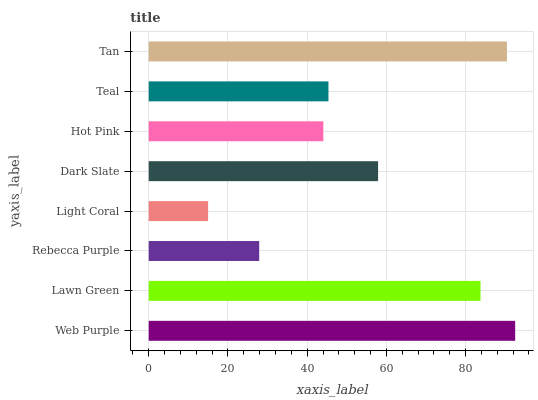Is Light Coral the minimum?
Answer yes or no. Yes. Is Web Purple the maximum?
Answer yes or no. Yes. Is Lawn Green the minimum?
Answer yes or no. No. Is Lawn Green the maximum?
Answer yes or no. No. Is Web Purple greater than Lawn Green?
Answer yes or no. Yes. Is Lawn Green less than Web Purple?
Answer yes or no. Yes. Is Lawn Green greater than Web Purple?
Answer yes or no. No. Is Web Purple less than Lawn Green?
Answer yes or no. No. Is Dark Slate the high median?
Answer yes or no. Yes. Is Teal the low median?
Answer yes or no. Yes. Is Teal the high median?
Answer yes or no. No. Is Dark Slate the low median?
Answer yes or no. No. 